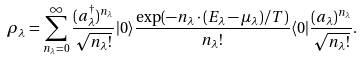<formula> <loc_0><loc_0><loc_500><loc_500>\rho _ { \lambda } = \sum _ { n _ { \lambda } = 0 } ^ { \infty } \frac { ( a _ { \lambda } ^ { \dagger } ) ^ { n _ { \lambda } } } { \sqrt { n _ { \lambda } ! } } | 0 \rangle \frac { \exp ( - n _ { \lambda } \cdot ( E _ { \lambda } - \mu _ { \lambda } ) / T ) } { n _ { \lambda } ! } \langle 0 | \frac { ( a _ { \lambda } ) ^ { n _ { \lambda } } } { \sqrt { n _ { \lambda } ! } } .</formula> 